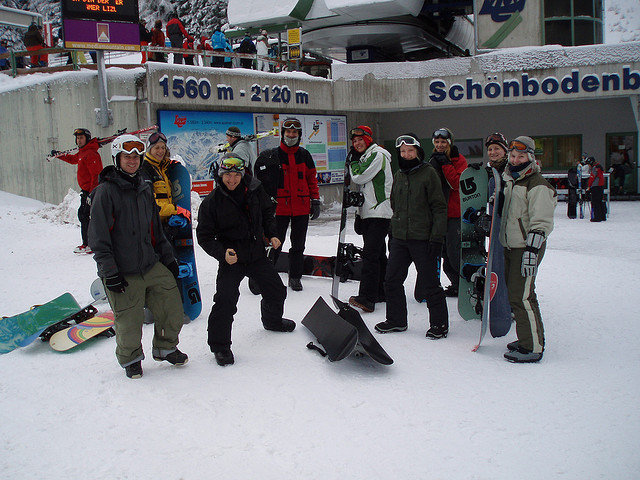Please transcribe the text in this image. 1560 m 2120 M 15 Schonbodenb 